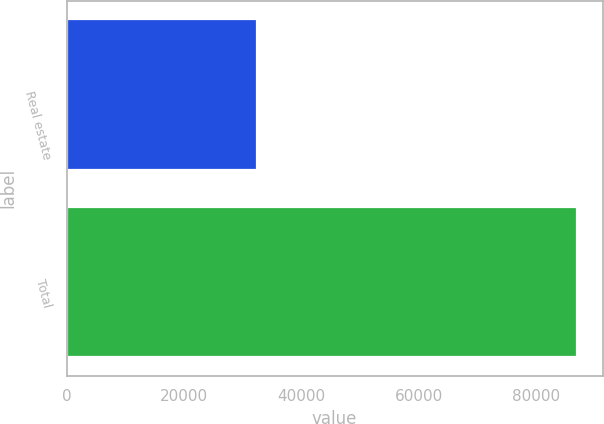Convert chart. <chart><loc_0><loc_0><loc_500><loc_500><bar_chart><fcel>Real estate<fcel>Total<nl><fcel>32392<fcel>86935<nl></chart> 